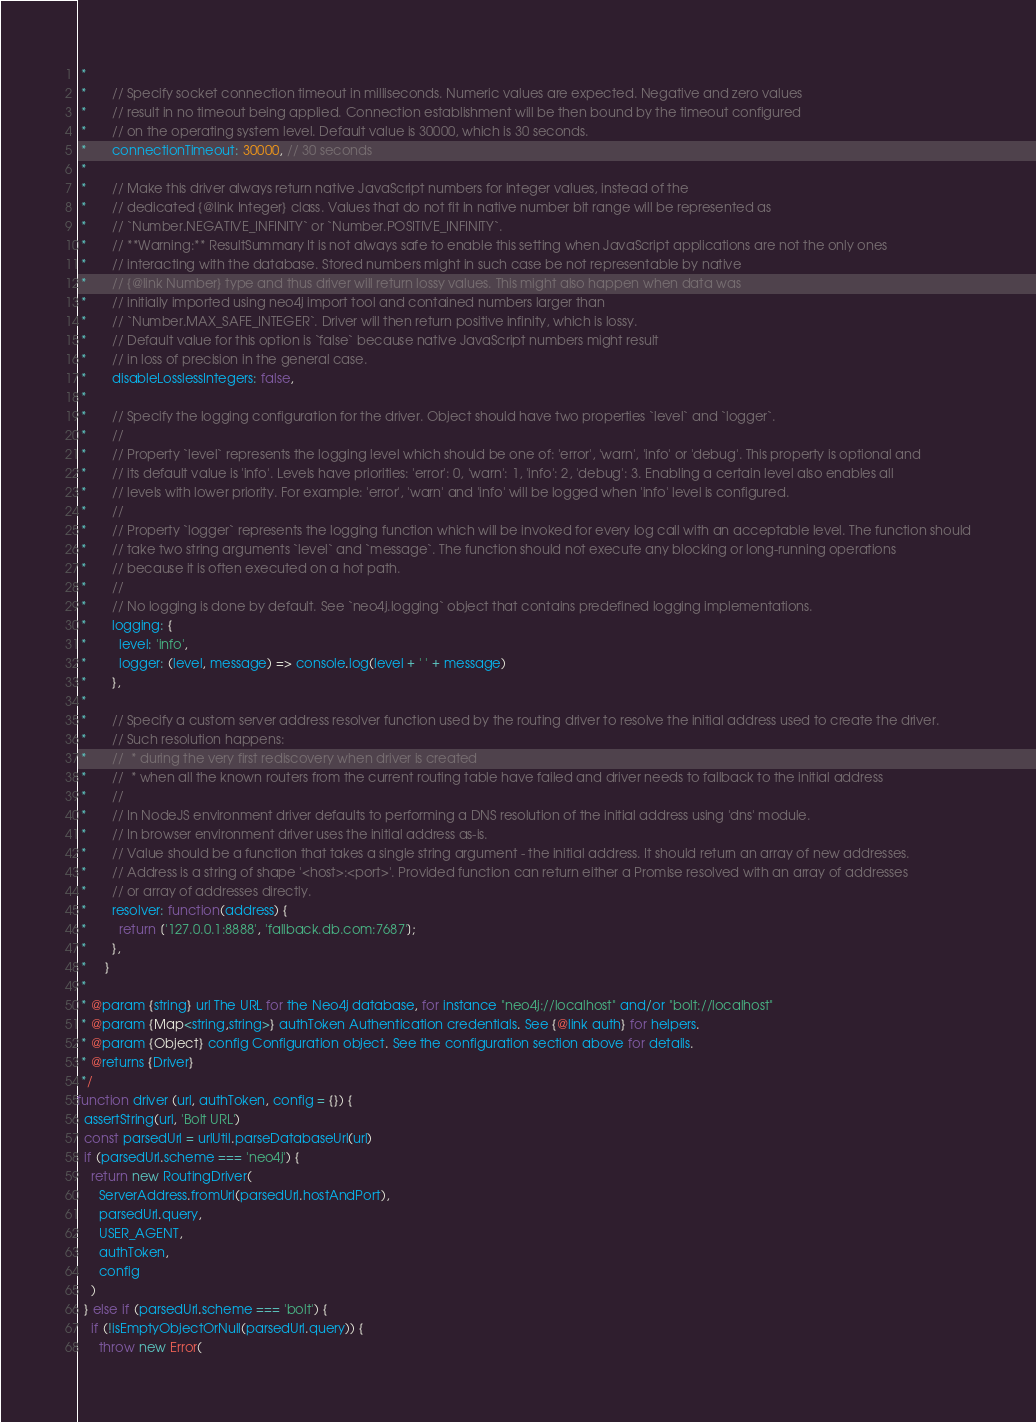Convert code to text. <code><loc_0><loc_0><loc_500><loc_500><_JavaScript_> *
 *       // Specify socket connection timeout in milliseconds. Numeric values are expected. Negative and zero values
 *       // result in no timeout being applied. Connection establishment will be then bound by the timeout configured
 *       // on the operating system level. Default value is 30000, which is 30 seconds.
 *       connectionTimeout: 30000, // 30 seconds
 *
 *       // Make this driver always return native JavaScript numbers for integer values, instead of the
 *       // dedicated {@link Integer} class. Values that do not fit in native number bit range will be represented as
 *       // `Number.NEGATIVE_INFINITY` or `Number.POSITIVE_INFINITY`.
 *       // **Warning:** ResultSummary It is not always safe to enable this setting when JavaScript applications are not the only ones
 *       // interacting with the database. Stored numbers might in such case be not representable by native
 *       // {@link Number} type and thus driver will return lossy values. This might also happen when data was
 *       // initially imported using neo4j import tool and contained numbers larger than
 *       // `Number.MAX_SAFE_INTEGER`. Driver will then return positive infinity, which is lossy.
 *       // Default value for this option is `false` because native JavaScript numbers might result
 *       // in loss of precision in the general case.
 *       disableLosslessIntegers: false,
 *
 *       // Specify the logging configuration for the driver. Object should have two properties `level` and `logger`.
 *       //
 *       // Property `level` represents the logging level which should be one of: 'error', 'warn', 'info' or 'debug'. This property is optional and
 *       // its default value is 'info'. Levels have priorities: 'error': 0, 'warn': 1, 'info': 2, 'debug': 3. Enabling a certain level also enables all
 *       // levels with lower priority. For example: 'error', 'warn' and 'info' will be logged when 'info' level is configured.
 *       //
 *       // Property `logger` represents the logging function which will be invoked for every log call with an acceptable level. The function should
 *       // take two string arguments `level` and `message`. The function should not execute any blocking or long-running operations
 *       // because it is often executed on a hot path.
 *       //
 *       // No logging is done by default. See `neo4j.logging` object that contains predefined logging implementations.
 *       logging: {
 *         level: 'info',
 *         logger: (level, message) => console.log(level + ' ' + message)
 *       },
 *
 *       // Specify a custom server address resolver function used by the routing driver to resolve the initial address used to create the driver.
 *       // Such resolution happens:
 *       //  * during the very first rediscovery when driver is created
 *       //  * when all the known routers from the current routing table have failed and driver needs to fallback to the initial address
 *       //
 *       // In NodeJS environment driver defaults to performing a DNS resolution of the initial address using 'dns' module.
 *       // In browser environment driver uses the initial address as-is.
 *       // Value should be a function that takes a single string argument - the initial address. It should return an array of new addresses.
 *       // Address is a string of shape '<host>:<port>'. Provided function can return either a Promise resolved with an array of addresses
 *       // or array of addresses directly.
 *       resolver: function(address) {
 *         return ['127.0.0.1:8888', 'fallback.db.com:7687'];
 *       },
 *     }
 *
 * @param {string} url The URL for the Neo4j database, for instance "neo4j://localhost" and/or "bolt://localhost"
 * @param {Map<string,string>} authToken Authentication credentials. See {@link auth} for helpers.
 * @param {Object} config Configuration object. See the configuration section above for details.
 * @returns {Driver}
 */
function driver (url, authToken, config = {}) {
  assertString(url, 'Bolt URL')
  const parsedUrl = urlUtil.parseDatabaseUrl(url)
  if (parsedUrl.scheme === 'neo4j') {
    return new RoutingDriver(
      ServerAddress.fromUrl(parsedUrl.hostAndPort),
      parsedUrl.query,
      USER_AGENT,
      authToken,
      config
    )
  } else if (parsedUrl.scheme === 'bolt') {
    if (!isEmptyObjectOrNull(parsedUrl.query)) {
      throw new Error(</code> 